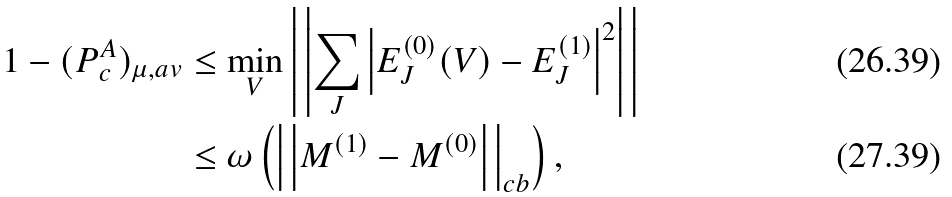Convert formula to latex. <formula><loc_0><loc_0><loc_500><loc_500>1 - ( P _ { c } ^ { A } ) _ { \mu , a v } & \leq \min _ { V } \left | \, \left | \sum _ { J } \left | E _ { J } ^ { ( 0 ) } ( V ) - E _ { J } ^ { ( 1 ) } \right | ^ { 2 } \right | \, \right | \\ & \leq \omega \left ( \left | \, \left | { M } ^ { ( 1 ) } - { M } ^ { ( 0 ) } \right | \, \right | _ { c b } \right ) ,</formula> 